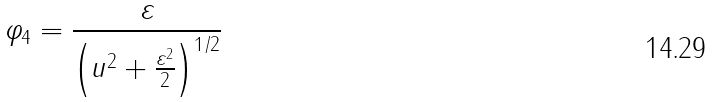<formula> <loc_0><loc_0><loc_500><loc_500>\varphi _ { 4 } = { \frac { \varepsilon } { \left ( u ^ { 2 } + { \frac { \varepsilon ^ { 2 } } { 2 } } \right ) ^ { 1 / 2 } } }</formula> 